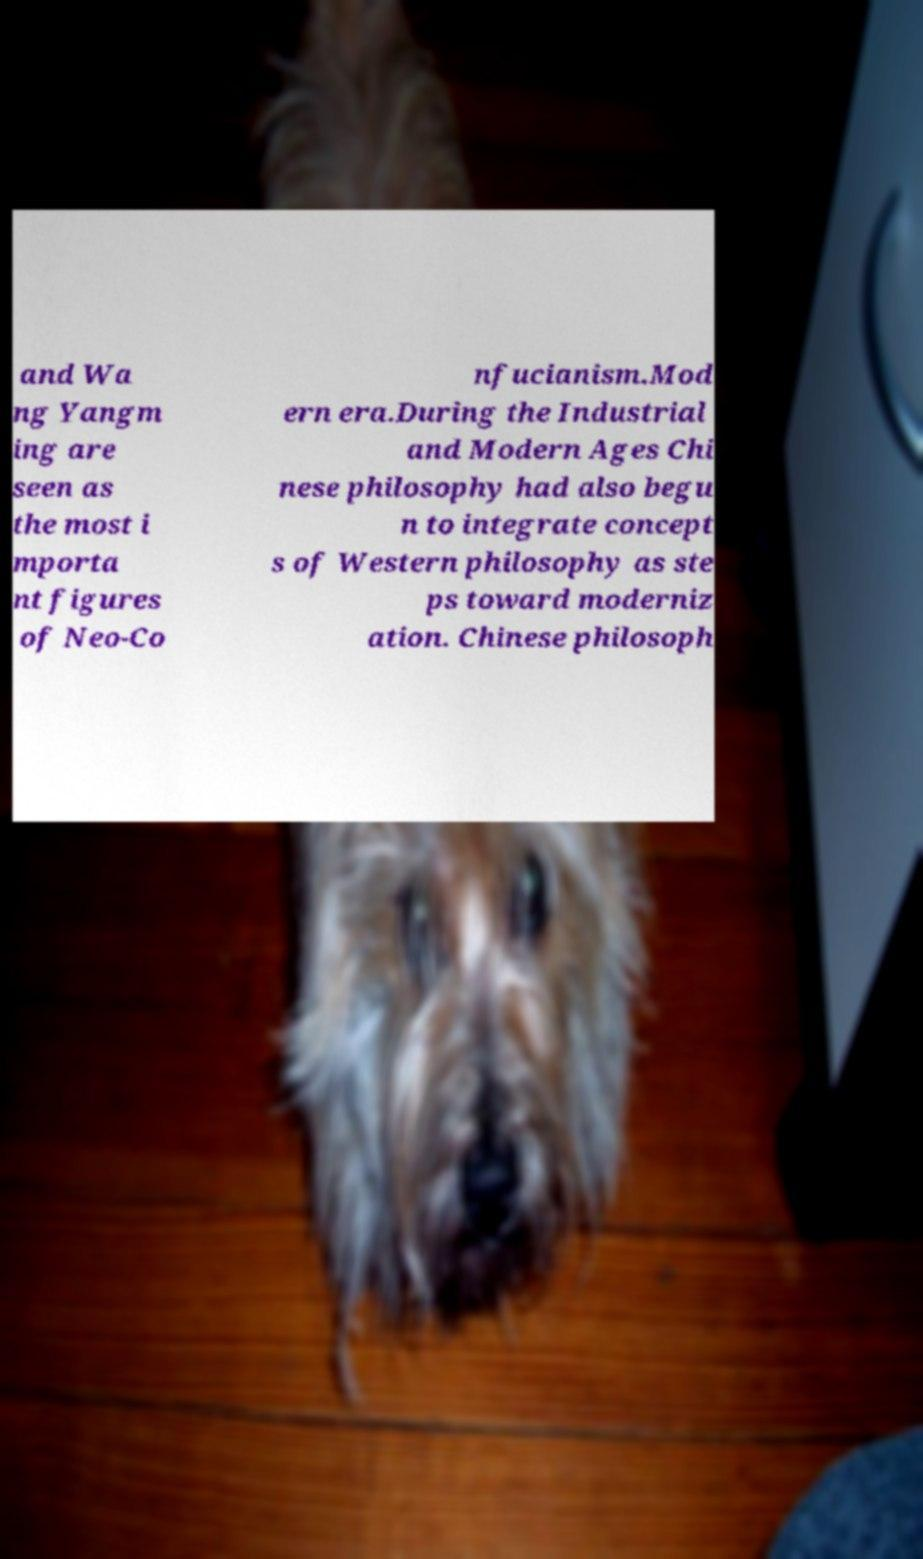There's text embedded in this image that I need extracted. Can you transcribe it verbatim? and Wa ng Yangm ing are seen as the most i mporta nt figures of Neo-Co nfucianism.Mod ern era.During the Industrial and Modern Ages Chi nese philosophy had also begu n to integrate concept s of Western philosophy as ste ps toward moderniz ation. Chinese philosoph 